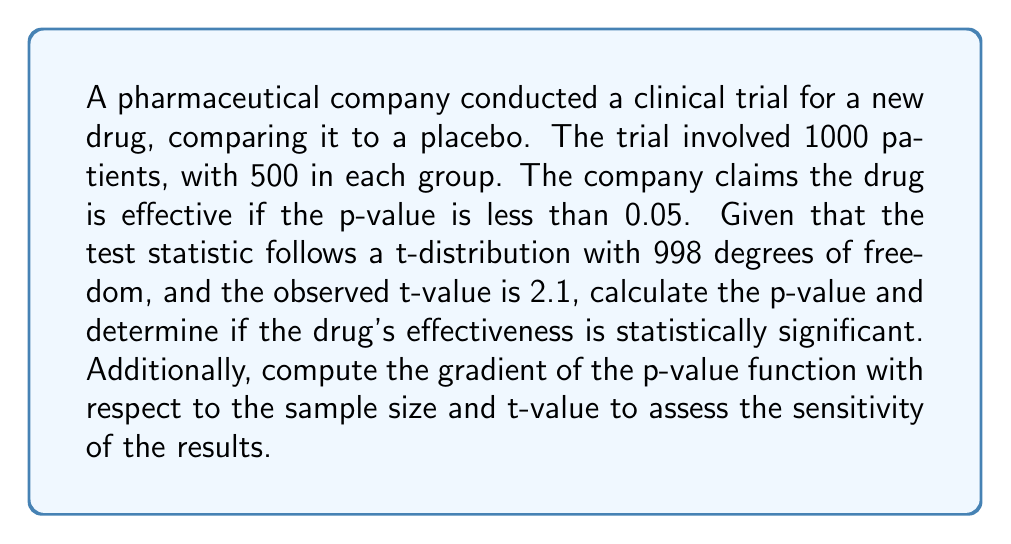Help me with this question. 1) First, we need to calculate the p-value for a two-tailed t-test:

   p-value = 2 * P(T > |t|), where T follows a t-distribution with 998 degrees of freedom

2) Using a t-distribution calculator or table, we find:
   P(T > 2.1) ≈ 0.0180

3) For a two-tailed test, we double this:
   p-value = 2 * 0.0180 = 0.0360

4) Since 0.0360 < 0.05, the result is statistically significant.

5) To calculate the gradient, we need to express the p-value as a function of n (sample size) and t (t-value):

   $$p(n,t) = 2 * (1 - F_t(t, n-2))$$

   where $F_t$ is the cumulative distribution function of the t-distribution.

6) The partial derivatives are:

   $$\frac{\partial p}{\partial n} = 2 * \frac{\partial}{\partial n}(1 - F_t(t, n-2))$$
   $$\frac{\partial p}{\partial t} = -2 * f_t(t, n-2)$$

   where $f_t$ is the probability density function of the t-distribution.

7) Evaluating these at n = 1000 and t = 2.1:

   $$\frac{\partial p}{\partial n} \approx -1.44 * 10^{-5}$$
   $$\frac{\partial p}{\partial t} \approx -0.0342$$

8) The gradient vector is therefore:

   $$\nabla p = \left(-1.44 * 10^{-5}, -0.0342\right)$$

This gradient indicates that the p-value is more sensitive to changes in the t-value than to changes in the sample size at this point.
Answer: p-value = 0.0360; statistically significant; $\nabla p = (-1.44 * 10^{-5}, -0.0342)$ 